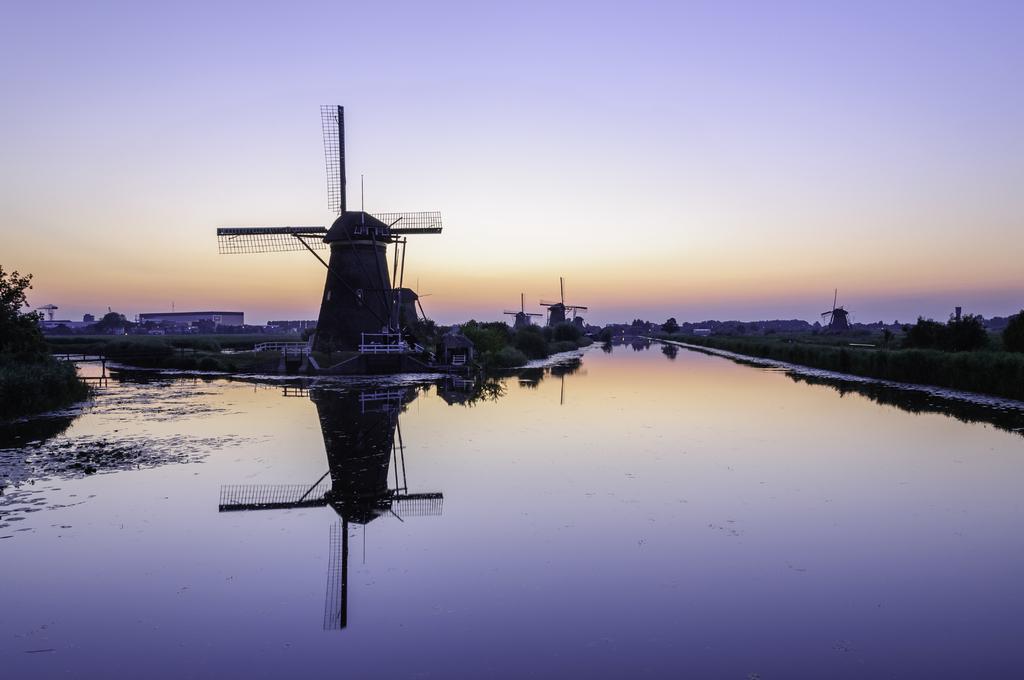Could you give a brief overview of what you see in this image? In this image we can see the canal and to the side we can see some windmills. There are some plants and trees and we can also see some building in the background. We can also see the sky. 